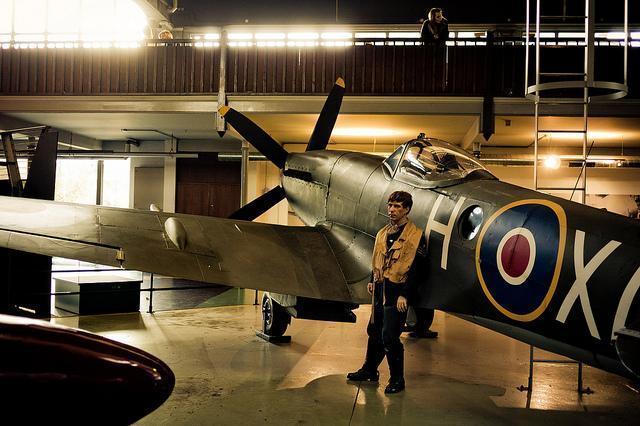How many airplanes are there?
Give a very brief answer. 2. 